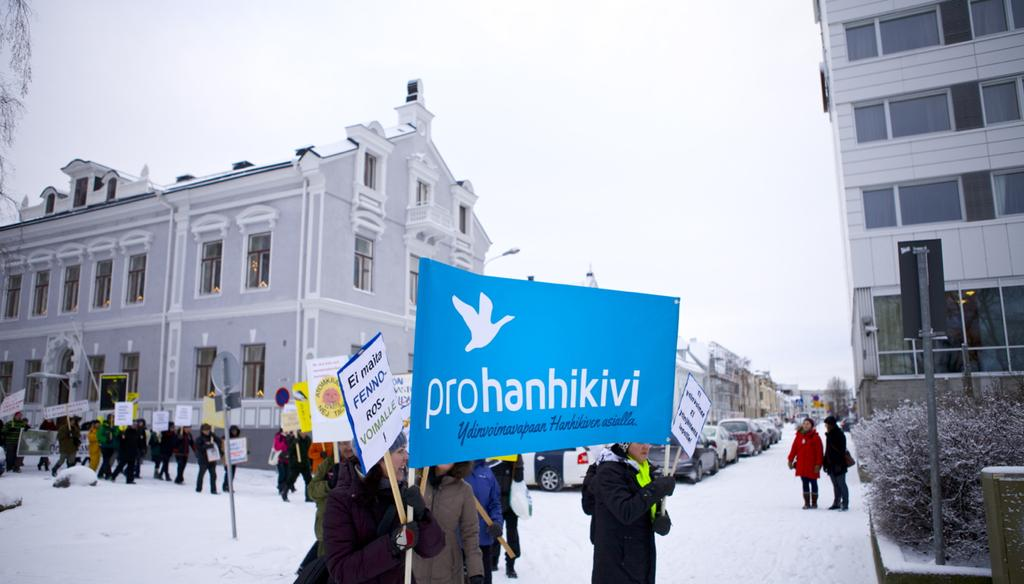<image>
Relay a brief, clear account of the picture shown. people holding a blue sign outside that says 'prohanhikivi' 